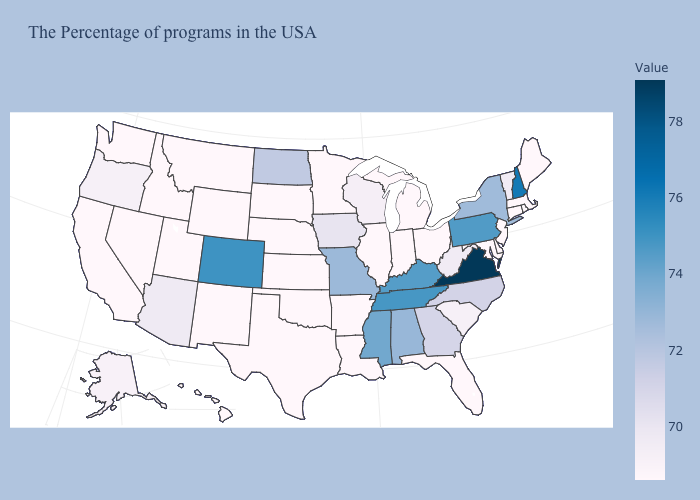Which states have the lowest value in the USA?
Concise answer only. Maine, Massachusetts, Connecticut, New Jersey, Delaware, Maryland, Ohio, Florida, Michigan, Indiana, Illinois, Louisiana, Arkansas, Minnesota, Kansas, Nebraska, Oklahoma, Texas, South Dakota, Wyoming, New Mexico, Utah, Montana, Idaho, Nevada, California, Washington, Hawaii. Does Nevada have the lowest value in the USA?
Write a very short answer. Yes. Which states have the lowest value in the USA?
Write a very short answer. Maine, Massachusetts, Connecticut, New Jersey, Delaware, Maryland, Ohio, Florida, Michigan, Indiana, Illinois, Louisiana, Arkansas, Minnesota, Kansas, Nebraska, Oklahoma, Texas, South Dakota, Wyoming, New Mexico, Utah, Montana, Idaho, Nevada, California, Washington, Hawaii. Does the map have missing data?
Give a very brief answer. No. Among the states that border Ohio , does Pennsylvania have the highest value?
Keep it brief. Yes. 